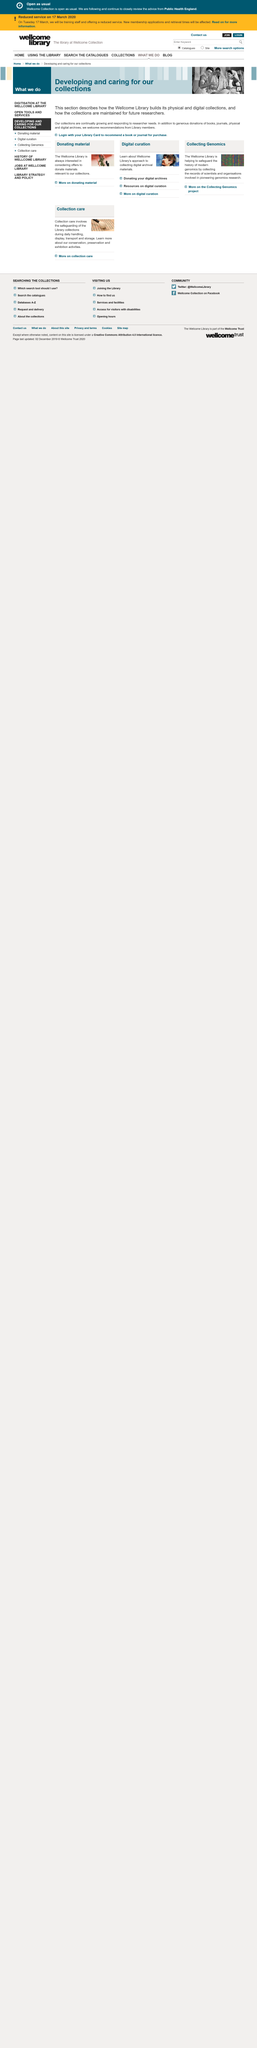Identify some key points in this picture. The Wellcome Library's physical and digital collections are built and maintained as described in this section, with specific focus on how they serve future researchers. Yes, there are donations of books at the Library. The Library accepts donations of books. 